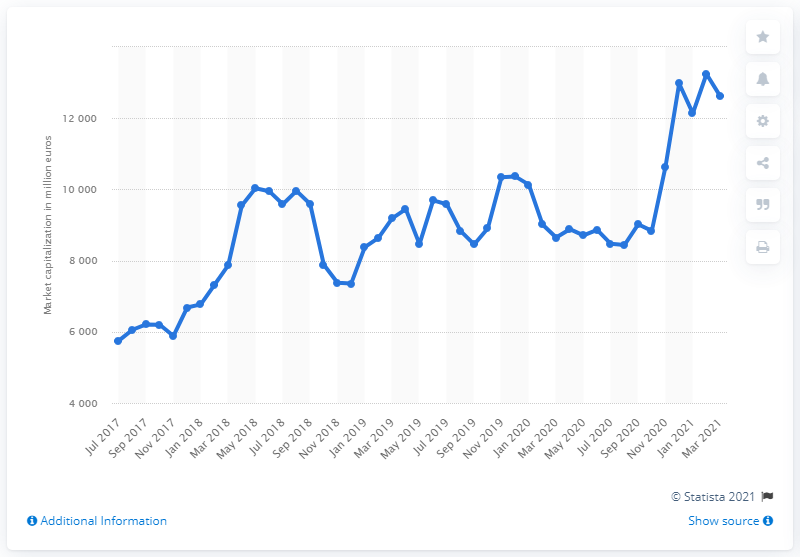Give some essential details in this illustration. In July 2017, Moncler's market capitalization was 5751.88. 